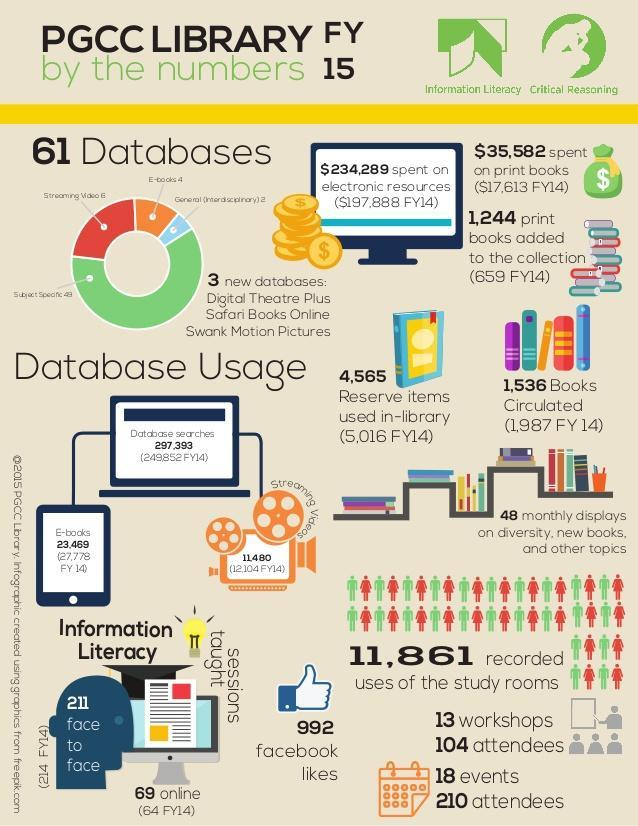How many Facebook likes?
Answer the question with a short phrase. 992 How many database searches? 297,393 